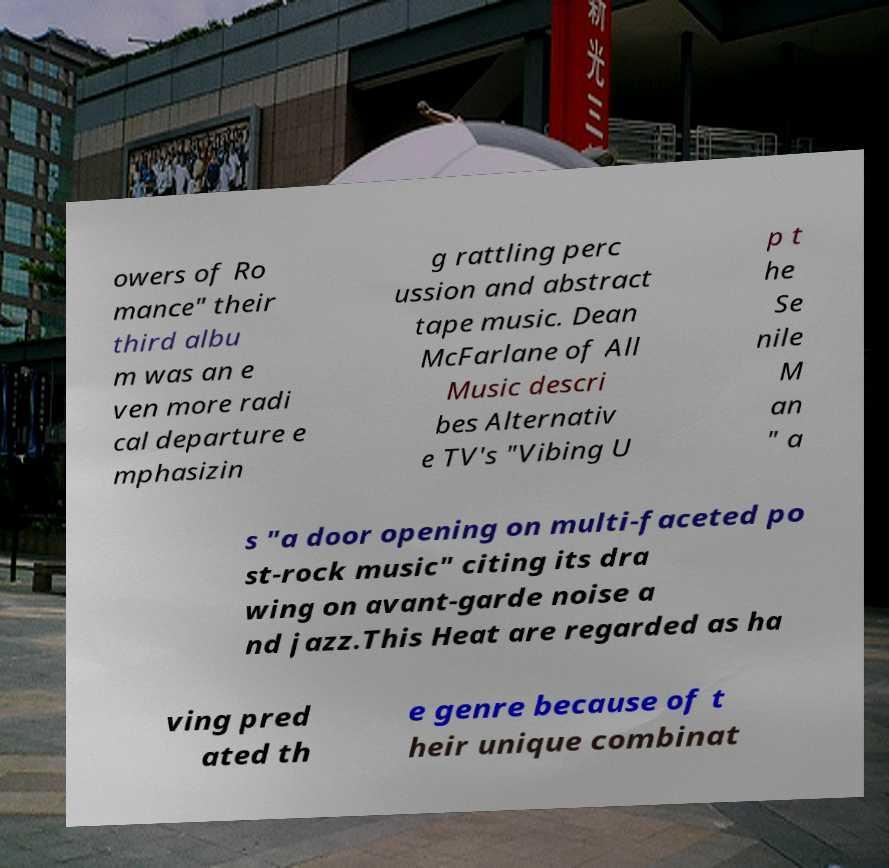Can you read and provide the text displayed in the image?This photo seems to have some interesting text. Can you extract and type it out for me? owers of Ro mance" their third albu m was an e ven more radi cal departure e mphasizin g rattling perc ussion and abstract tape music. Dean McFarlane of All Music descri bes Alternativ e TV's "Vibing U p t he Se nile M an " a s "a door opening on multi-faceted po st-rock music" citing its dra wing on avant-garde noise a nd jazz.This Heat are regarded as ha ving pred ated th e genre because of t heir unique combinat 